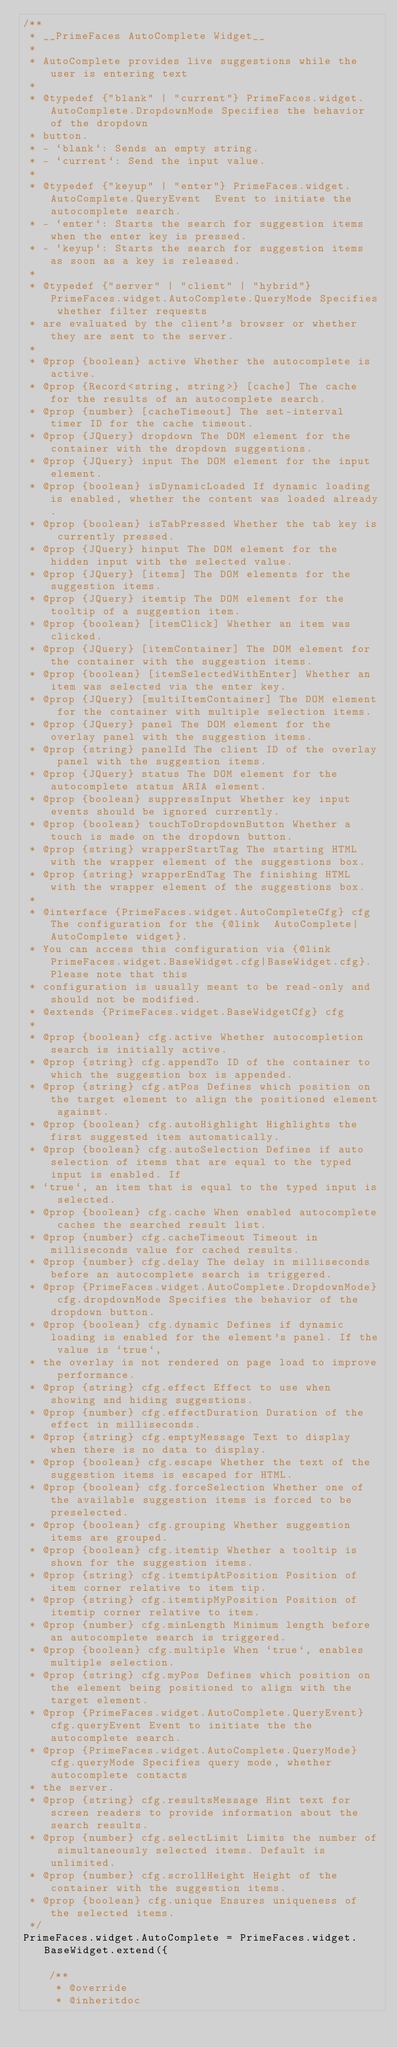<code> <loc_0><loc_0><loc_500><loc_500><_JavaScript_>/**
 * __PrimeFaces AutoComplete Widget__
 * 
 * AutoComplete provides live suggestions while the user is entering text
 * 
 * @typedef {"blank" | "current"} PrimeFaces.widget.AutoComplete.DropdownMode Specifies the behavior of the dropdown
 * button.
 * - `blank`: Sends an empty string.
 * - `current`: Send the input value.
 * 
 * @typedef {"keyup" | "enter"} PrimeFaces.widget.AutoComplete.QueryEvent  Event to initiate the autocomplete search.
 * - `enter`: Starts the search for suggestion items when the enter key is pressed.
 * - `keyup`: Starts the search for suggestion items as soon as a key is released.
 * 
 * @typedef {"server" | "client" | "hybrid"} PrimeFaces.widget.AutoComplete.QueryMode Specifies whether filter requests
 * are evaluated by the client's browser or whether they are sent to the server.
 * 
 * @prop {boolean} active Whether the autocomplete is active.
 * @prop {Record<string, string>} [cache] The cache for the results of an autocomplete search.
 * @prop {number} [cacheTimeout] The set-interval timer ID for the cache timeout. 
 * @prop {JQuery} dropdown The DOM element for the container with the dropdown suggestions.
 * @prop {JQuery} input The DOM element for the input element.
 * @prop {boolean} isDynamicLoaded If dynamic loading is enabled, whether the content was loaded already.
 * @prop {boolean} isTabPressed Whether the tab key is currently pressed.
 * @prop {JQuery} hinput The DOM element for the hidden input with the selected value.
 * @prop {JQuery} [items] The DOM elements for the suggestion items.
 * @prop {JQuery} itemtip The DOM element for the tooltip of a suggestion item.
 * @prop {boolean} [itemClick] Whether an item was clicked.
 * @prop {JQuery} [itemContainer] The DOM element for the container with the suggestion items.
 * @prop {boolean} [itemSelectedWithEnter] Whether an item was selected via the enter key.
 * @prop {JQuery} [multiItemContainer] The DOM element for the container with multiple selection items.
 * @prop {JQuery} panel The DOM element for the overlay panel with the suggestion items. 
 * @prop {string} panelId The client ID of the overlay panel with the suggestion items.
 * @prop {JQuery} status The DOM element for the autocomplete status ARIA element.
 * @prop {boolean} suppressInput Whether key input events should be ignored currently.
 * @prop {boolean} touchToDropdownButton Whether a touch is made on the dropdown button.
 * @prop {string} wrapperStartTag The starting HTML with the wrapper element of the suggestions box.  
 * @prop {string} wrapperEndTag The finishing HTML with the wrapper element of the suggestions box.
 * 
 * @interface {PrimeFaces.widget.AutoCompleteCfg} cfg The configuration for the {@link  AutoComplete| AutoComplete widget}.
 * You can access this configuration via {@link PrimeFaces.widget.BaseWidget.cfg|BaseWidget.cfg}. Please note that this
 * configuration is usually meant to be read-only and should not be modified.
 * @extends {PrimeFaces.widget.BaseWidgetCfg} cfg
 * 
 * @prop {boolean} cfg.active Whether autocompletion search is initially active.
 * @prop {string} cfg.appendTo ID of the container to which the suggestion box is appended.
 * @prop {string} cfg.atPos Defines which position on the target element to align the positioned element against.
 * @prop {boolean} cfg.autoHighlight Highlights the first suggested item automatically.
 * @prop {boolean} cfg.autoSelection Defines if auto selection of items that are equal to the typed input is enabled. If
 * `true`, an item that is equal to the typed input is selected.
 * @prop {boolean} cfg.cache When enabled autocomplete caches the searched result list.
 * @prop {number} cfg.cacheTimeout Timeout in milliseconds value for cached results.
 * @prop {number} cfg.delay The delay in milliseconds before an autocomplete search is triggered.
 * @prop {PrimeFaces.widget.AutoComplete.DropdownMode} cfg.dropdownMode Specifies the behavior of the dropdown button.
 * @prop {boolean} cfg.dynamic Defines if dynamic loading is enabled for the element's panel. If the value is `true`,
 * the overlay is not rendered on page load to improve performance.
 * @prop {string} cfg.effect Effect to use when showing and hiding suggestions.
 * @prop {number} cfg.effectDuration Duration of the effect in milliseconds.
 * @prop {string} cfg.emptyMessage Text to display when there is no data to display.
 * @prop {boolean} cfg.escape Whether the text of the suggestion items is escaped for HTML.
 * @prop {boolean} cfg.forceSelection Whether one of the available suggestion items is forced to be preselected.
 * @prop {boolean} cfg.grouping Whether suggestion items are grouped.
 * @prop {boolean} cfg.itemtip Whether a tooltip is shown for the suggestion items.
 * @prop {string} cfg.itemtipAtPosition Position of item corner relative to item tip.
 * @prop {string} cfg.itemtipMyPosition Position of itemtip corner relative to item.
 * @prop {number} cfg.minLength Minimum length before an autocomplete search is triggered.
 * @prop {boolean} cfg.multiple When `true`, enables multiple selection.
 * @prop {string} cfg.myPos Defines which position on the element being positioned to align with the target element.
 * @prop {PrimeFaces.widget.AutoComplete.QueryEvent} cfg.queryEvent Event to initiate the the autocomplete search.
 * @prop {PrimeFaces.widget.AutoComplete.QueryMode} cfg.queryMode Specifies query mode, whether autocomplete contacts
 * the server.
 * @prop {string} cfg.resultsMessage Hint text for screen readers to provide information about the search results.
 * @prop {number} cfg.selectLimit Limits the number of simultaneously selected items. Default is unlimited.
 * @prop {number} cfg.scrollHeight Height of the container with the suggestion items.
 * @prop {boolean} cfg.unique Ensures uniqueness of the selected items.
 */
PrimeFaces.widget.AutoComplete = PrimeFaces.widget.BaseWidget.extend({

    /**
     * @override
     * @inheritdoc</code> 